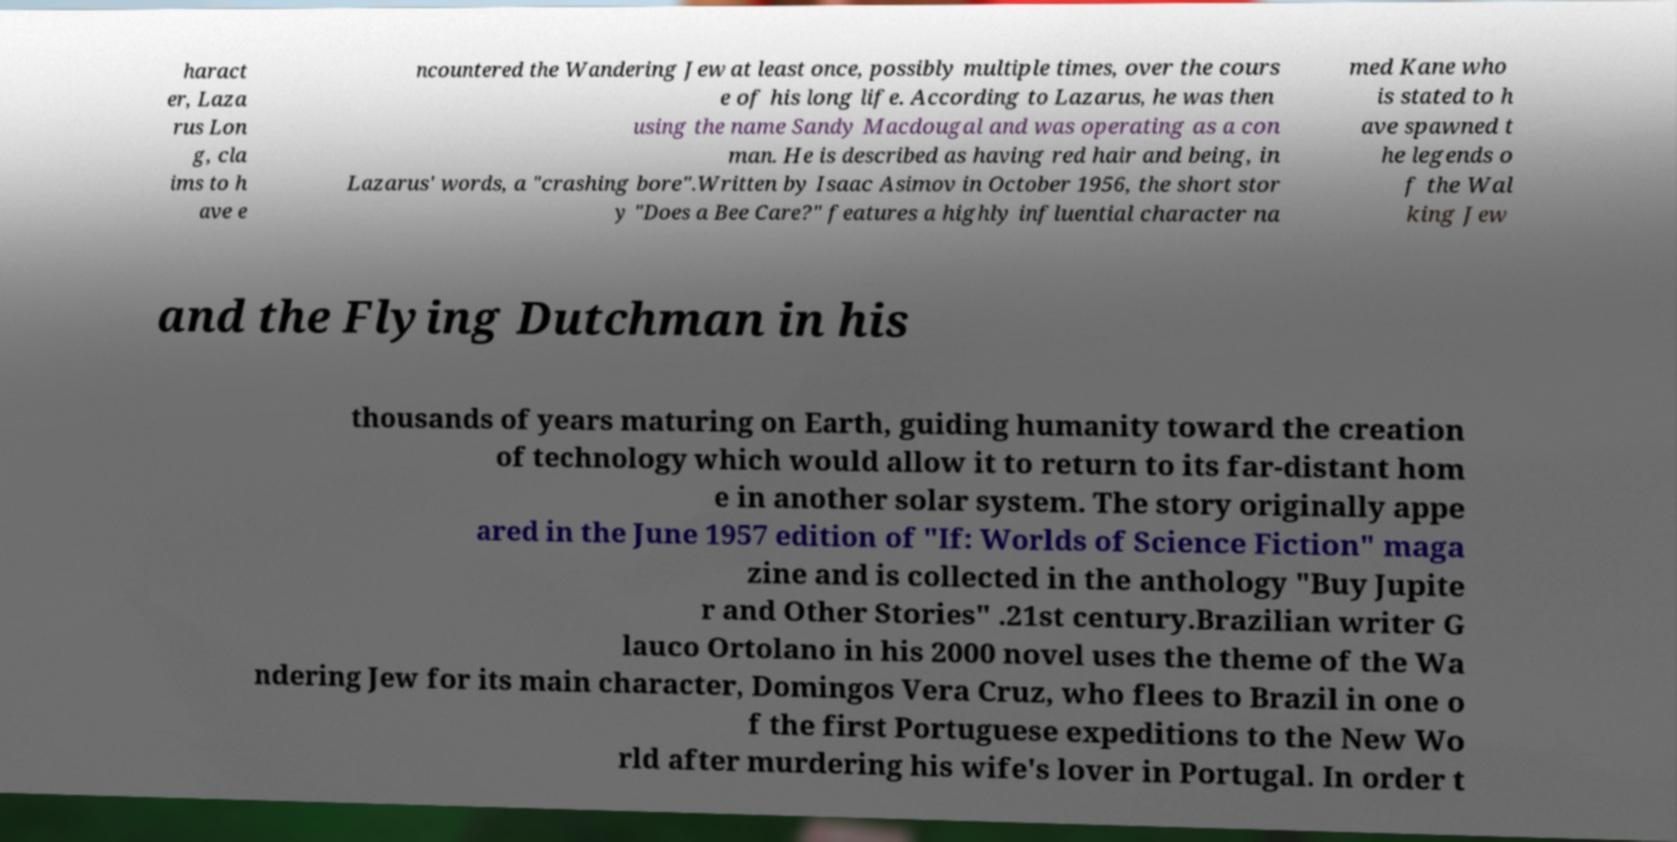Can you accurately transcribe the text from the provided image for me? haract er, Laza rus Lon g, cla ims to h ave e ncountered the Wandering Jew at least once, possibly multiple times, over the cours e of his long life. According to Lazarus, he was then using the name Sandy Macdougal and was operating as a con man. He is described as having red hair and being, in Lazarus' words, a "crashing bore".Written by Isaac Asimov in October 1956, the short stor y "Does a Bee Care?" features a highly influential character na med Kane who is stated to h ave spawned t he legends o f the Wal king Jew and the Flying Dutchman in his thousands of years maturing on Earth, guiding humanity toward the creation of technology which would allow it to return to its far-distant hom e in another solar system. The story originally appe ared in the June 1957 edition of "If: Worlds of Science Fiction" maga zine and is collected in the anthology "Buy Jupite r and Other Stories" .21st century.Brazilian writer G lauco Ortolano in his 2000 novel uses the theme of the Wa ndering Jew for its main character, Domingos Vera Cruz, who flees to Brazil in one o f the first Portuguese expeditions to the New Wo rld after murdering his wife's lover in Portugal. In order t 